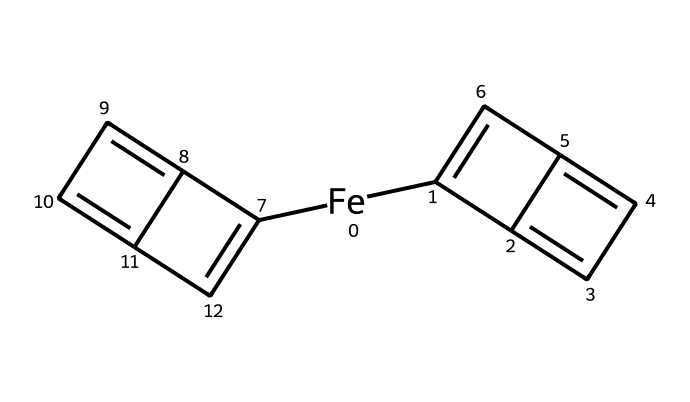How many iron atoms are present in ferrocene? The SMILES notation indicates one iron atom, which is represented as "[Fe]". This is a straightforward identification from the structure provided.
Answer: one What is the overall structure of ferrocene? The SMILES representation shows a compound with two cyclopentadienyl rings sandwiching an iron atom. This matches the known structure of ferrocene, characterized as a metallocene.
Answer: metallocene How many carbon atoms are in ferrocene? The structure contains five carbon atoms from each of the two cyclopentadienyl rings, totaling ten carbon atoms. Each ring has a five-membered structure.
Answer: ten What type of bonding is present between the iron and the cyclopentadienyl rings? The bonding type is pi-bonding as the cyclopentadienyl rings donate electron density through their overlapping p-orbitals to the iron center. This is typical in organometallics.
Answer: pi-bonding What is the symmetry of the ferrocene molecule? The molecule has a symmetrical structure due to the arrangement of the two identical cyclopentadienyl rings around the iron atom, making it a symmetric organometallic compound.
Answer: symmetric Is ferrocene a stable compound? Yes, ferrocene is known for its stability due to the strong bond between the iron and cyclopentadienyl rings, which prevents it from easily decomposing under normal conditions.
Answer: yes 